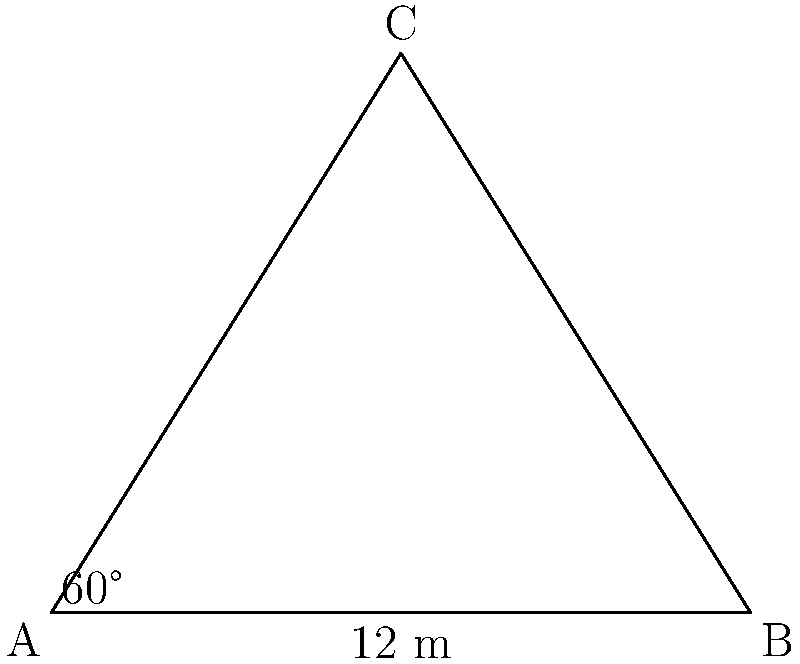A triangular sports banner is being designed for a national badminton tournament in Georgia. The base of the banner is 12 meters long, and one of the angles at the base is 60°. Calculate the area of the banner in square meters. Let's approach this step-by-step:

1) We have a triangle with a known base (12 m) and a known angle (60°). We need to find the area.

2) The formula for the area of a triangle is:
   $$A = \frac{1}{2} \times base \times height$$

3) We know the base (12 m), but we need to find the height.

4) In a right-angled triangle, we can use the tangent ratio to find the height:
   $$\tan 60° = \frac{height}{6}$$
   (Note: 6 is half of the base, as we're considering the right-angled triangle formed by the height)

5) We know that $\tan 60° = \sqrt{3}$, so:
   $$\sqrt{3} = \frac{height}{6}$$

6) Solving for height:
   $$height = 6\sqrt{3}$$

7) Now we can calculate the area:
   $$A = \frac{1}{2} \times 12 \times 6\sqrt{3}$$

8) Simplifying:
   $$A = 36\sqrt{3}$$

Therefore, the area of the banner is $36\sqrt{3}$ square meters.
Answer: $36\sqrt{3}$ m² 